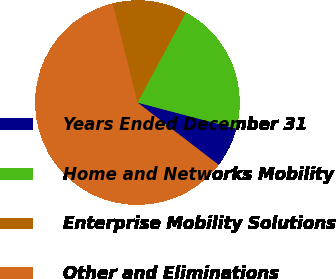<chart> <loc_0><loc_0><loc_500><loc_500><pie_chart><fcel>Years Ended December 31<fcel>Home and Networks Mobility<fcel>Enterprise Mobility Solutions<fcel>Other and Eliminations<nl><fcel>6.32%<fcel>21.25%<fcel>11.75%<fcel>60.68%<nl></chart> 